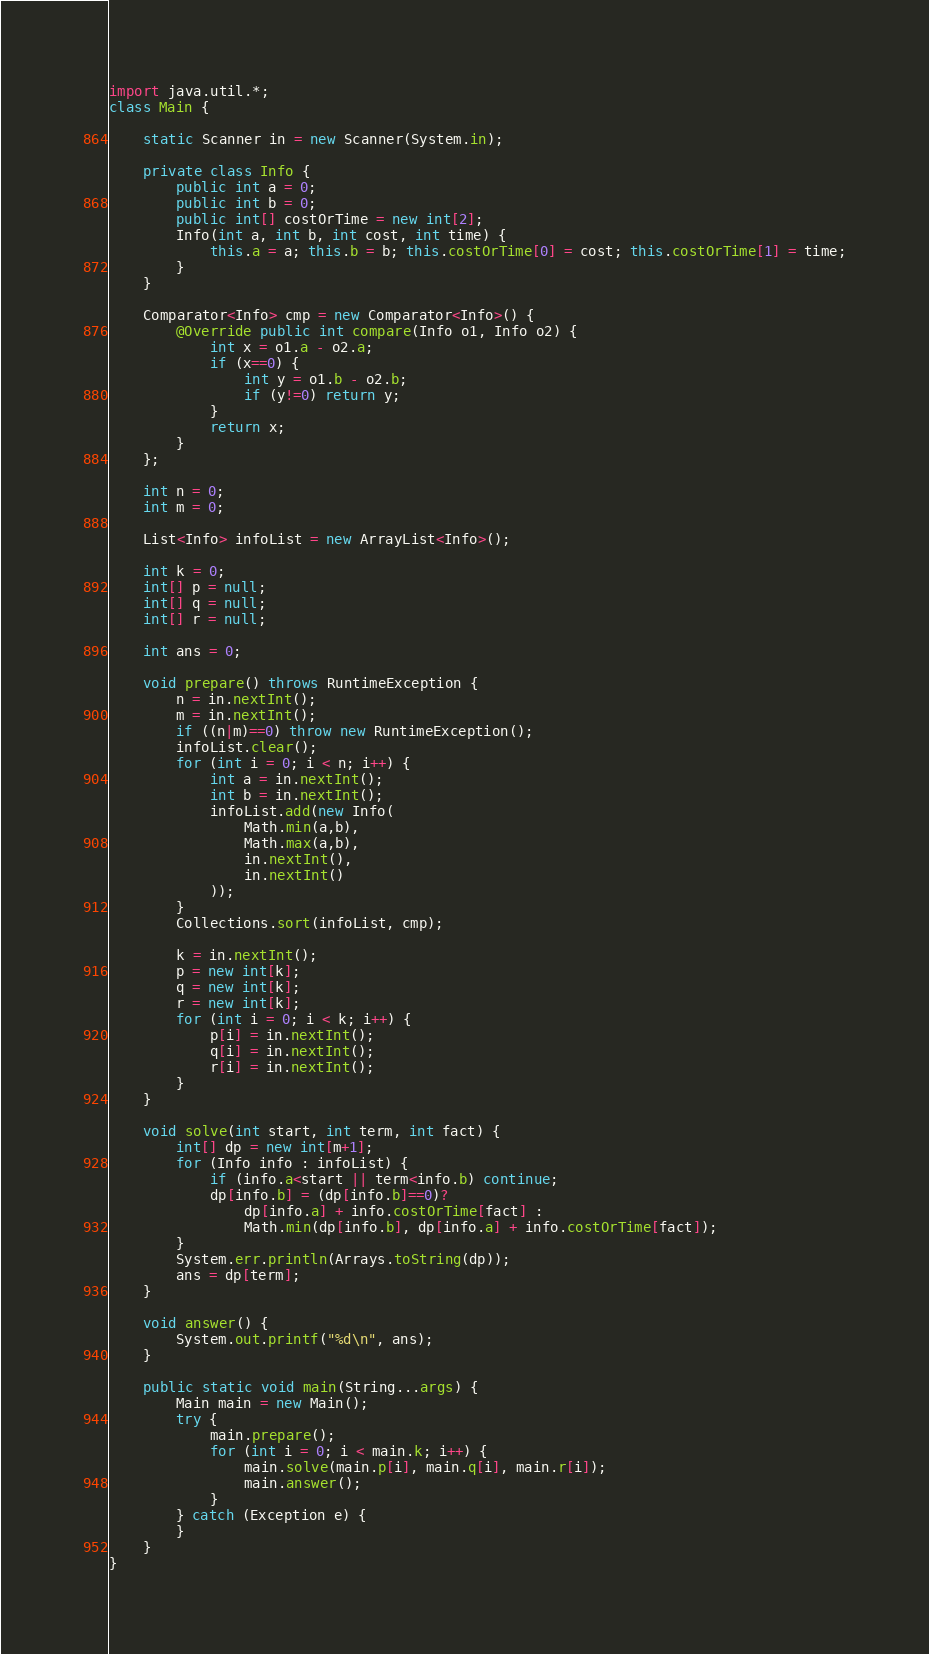Convert code to text. <code><loc_0><loc_0><loc_500><loc_500><_Java_>import java.util.*;
class Main {

	static Scanner in = new Scanner(System.in);

	private class Info {
		public int a = 0;
		public int b = 0;
		public int[] costOrTime = new int[2];
		Info(int a, int b, int cost, int time) {
			this.a = a; this.b = b; this.costOrTime[0] = cost; this.costOrTime[1] = time;
		}
	}

	Comparator<Info> cmp = new Comparator<Info>() {
		@Override public int compare(Info o1, Info o2) {
			int x = o1.a - o2.a;
			if (x==0) {
				int y = o1.b - o2.b;
				if (y!=0) return y;
			}
			return x;
		}
	};

	int n = 0;
	int m = 0;

	List<Info> infoList = new ArrayList<Info>();

	int k = 0;
	int[] p = null;
	int[] q = null;
	int[] r = null;

	int ans = 0;

	void prepare() throws RuntimeException {
		n = in.nextInt();
		m = in.nextInt();
		if ((n|m)==0) throw new RuntimeException();
		infoList.clear();
		for (int i = 0; i < n; i++) {
			int a = in.nextInt();
			int b = in.nextInt();
			infoList.add(new Info(
				Math.min(a,b),
				Math.max(a,b),
				in.nextInt(),
				in.nextInt()
			));
		}
		Collections.sort(infoList, cmp);

		k = in.nextInt();
		p = new int[k];
		q = new int[k];
		r = new int[k];
		for (int i = 0; i < k; i++) {
			p[i] = in.nextInt();
			q[i] = in.nextInt();
			r[i] = in.nextInt();
		}
	}

	void solve(int start, int term, int fact) {
		int[] dp = new int[m+1];
		for (Info info : infoList) {
			if (info.a<start || term<info.b) continue;
			dp[info.b] = (dp[info.b]==0)?
				dp[info.a] + info.costOrTime[fact] :
				Math.min(dp[info.b], dp[info.a] + info.costOrTime[fact]);
		}
		System.err.println(Arrays.toString(dp));
		ans = dp[term];
	}

	void answer() {
		System.out.printf("%d\n", ans);
	}

	public static void main(String...args) {
		Main main = new Main();
		try {
			main.prepare();
			for (int i = 0; i < main.k; i++) {
				main.solve(main.p[i], main.q[i], main.r[i]);
				main.answer();
			}
		} catch (Exception e) {
		}
	}
}</code> 